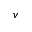<formula> <loc_0><loc_0><loc_500><loc_500>v</formula> 